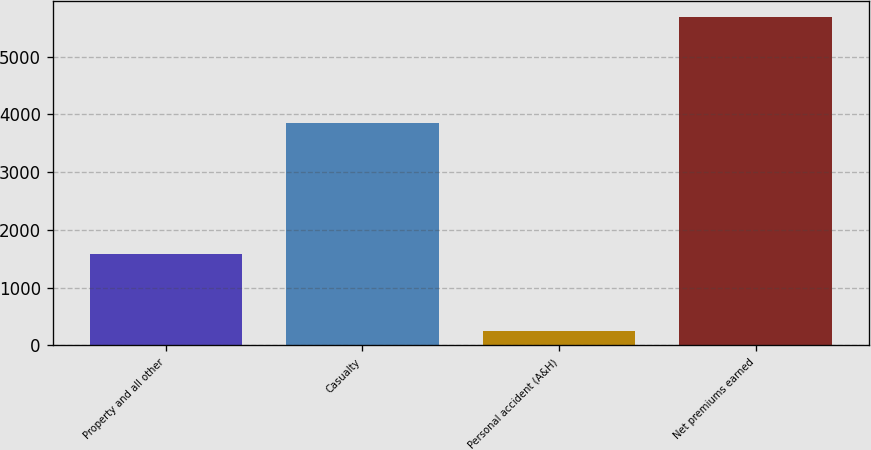Convert chart. <chart><loc_0><loc_0><loc_500><loc_500><bar_chart><fcel>Property and all other<fcel>Casualty<fcel>Personal accident (A&H)<fcel>Net premiums earned<nl><fcel>1576<fcel>3857<fcel>246<fcel>5679<nl></chart> 